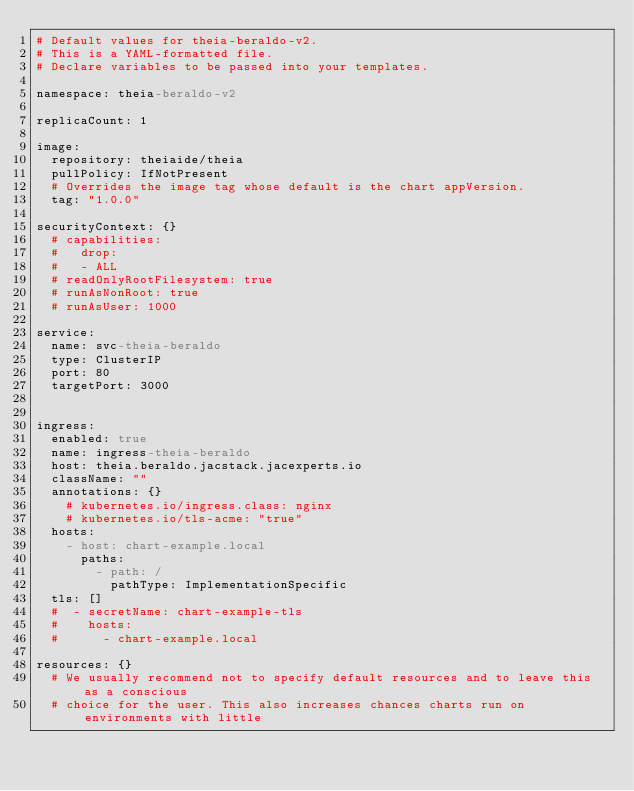Convert code to text. <code><loc_0><loc_0><loc_500><loc_500><_YAML_># Default values for theia-beraldo-v2.
# This is a YAML-formatted file.
# Declare variables to be passed into your templates.

namespace: theia-beraldo-v2

replicaCount: 1

image:
  repository: theiaide/theia
  pullPolicy: IfNotPresent
  # Overrides the image tag whose default is the chart appVersion.
  tag: "1.0.0"

securityContext: {}
  # capabilities:
  #   drop:
  #   - ALL
  # readOnlyRootFilesystem: true
  # runAsNonRoot: true
  # runAsUser: 1000

service:
  name: svc-theia-beraldo
  type: ClusterIP
  port: 80
  targetPort: 3000


ingress:
  enabled: true
  name: ingress-theia-beraldo
  host: theia.beraldo.jacstack.jacexperts.io
  className: ""
  annotations: {}
    # kubernetes.io/ingress.class: nginx
    # kubernetes.io/tls-acme: "true"
  hosts:
    - host: chart-example.local
      paths:
        - path: /
          pathType: ImplementationSpecific
  tls: []
  #  - secretName: chart-example-tls
  #    hosts:
  #      - chart-example.local

resources: {}
  # We usually recommend not to specify default resources and to leave this as a conscious
  # choice for the user. This also increases chances charts run on environments with little</code> 